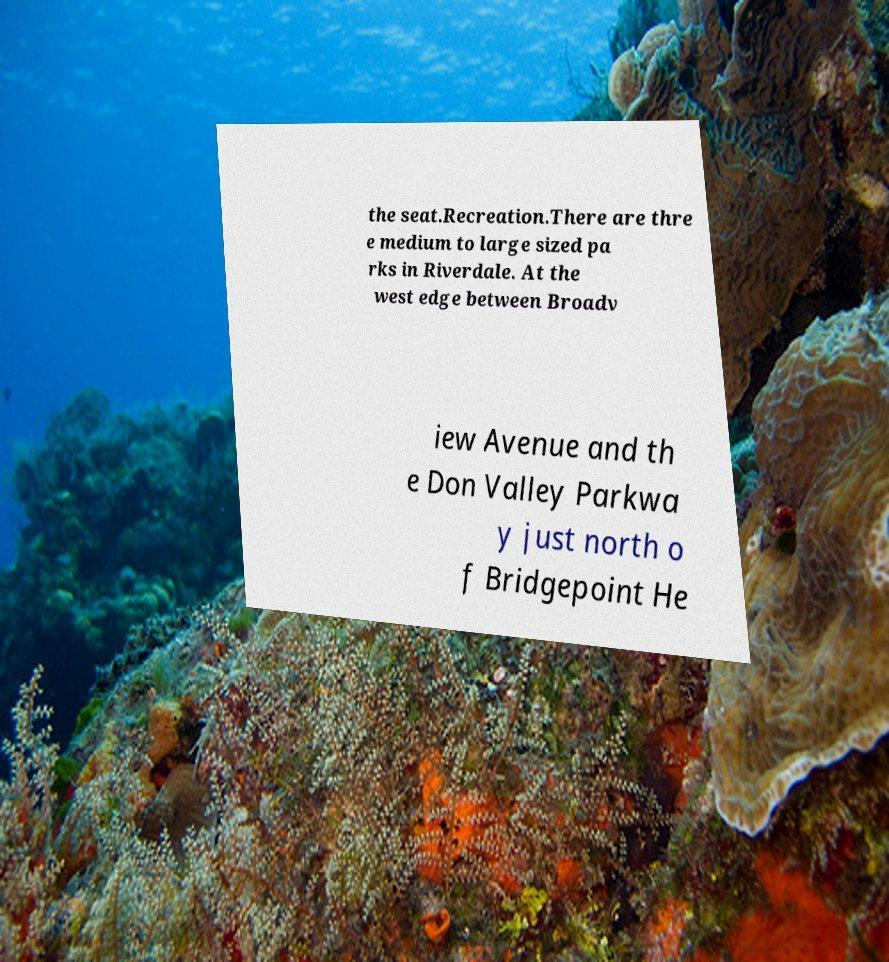Could you extract and type out the text from this image? the seat.Recreation.There are thre e medium to large sized pa rks in Riverdale. At the west edge between Broadv iew Avenue and th e Don Valley Parkwa y just north o f Bridgepoint He 